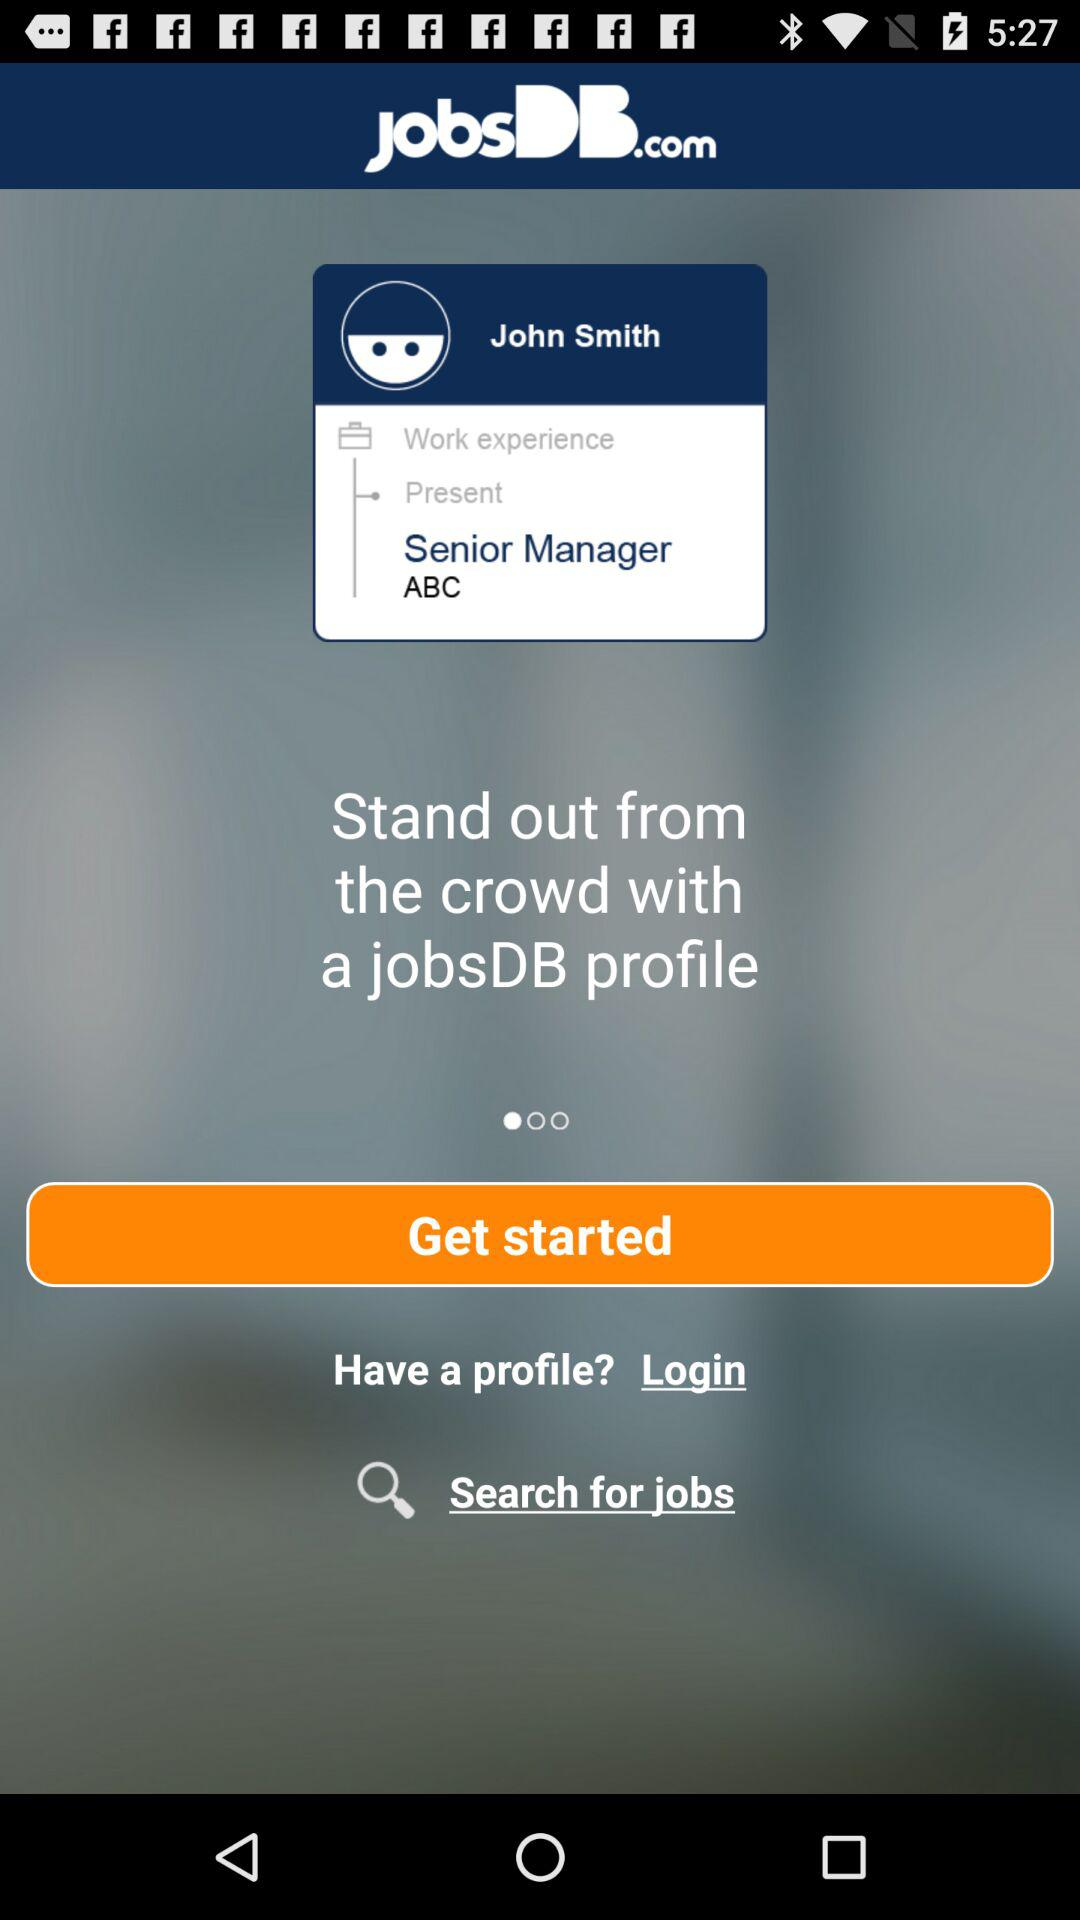What is the post? The post is Senior Manager. 